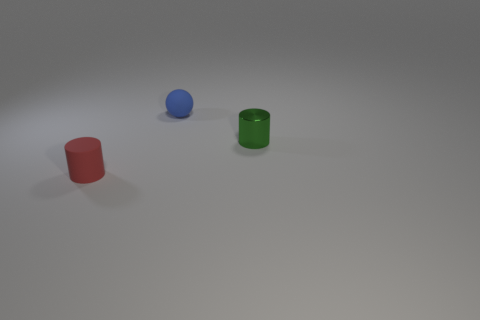What number of green objects are either tiny matte balls or small matte cylinders? In the image, there is one green object, which is a small matte cylinder. There are no tiny matte balls present. 